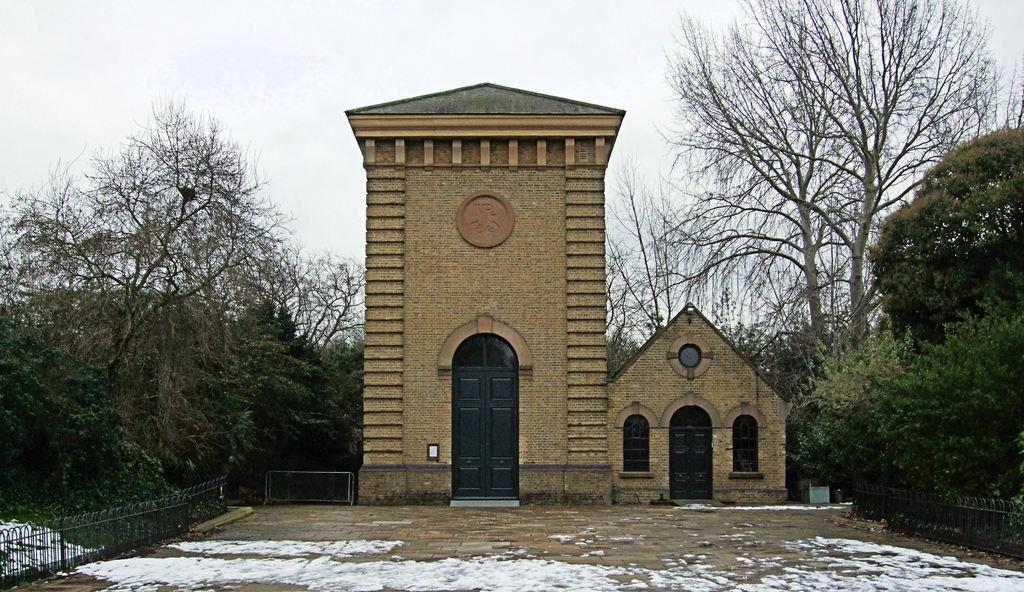What type of structures can be seen in the image? There are buildings in the image. What is separating the buildings from the background? There is a fence in the image. What can be seen in the distance behind the buildings and fence? There are trees in the background of the image. Where is the orange pig located in the image? There is no orange pig present in the image. 